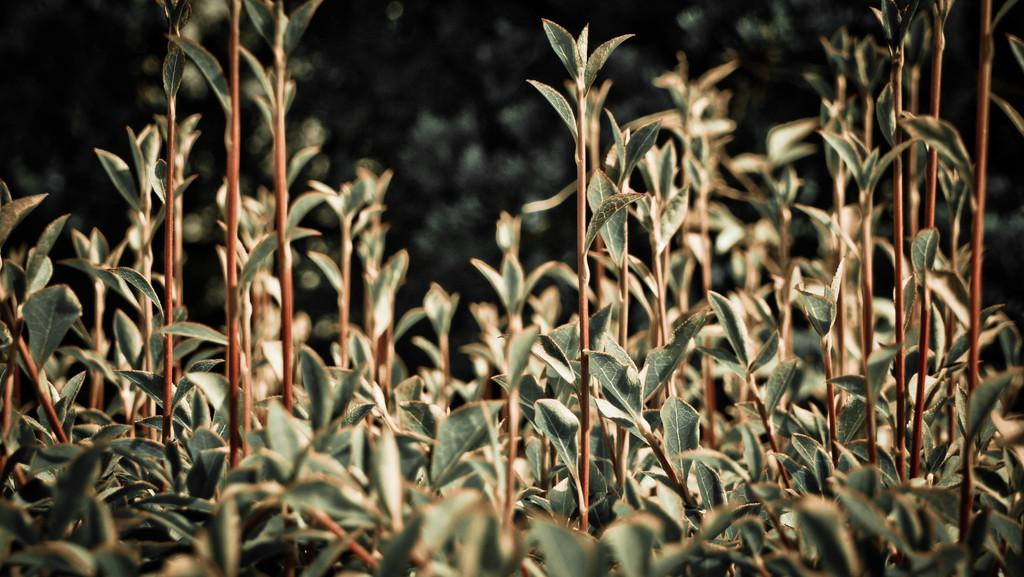What type of living organisms are in the image? There are plants in the image. What colors can be seen on the plants? The plants have green and brown colors. How would you describe the background of the image? The background of the image is blurry and has black and green colors. How many holes can be seen in the plants in the image? There are no holes visible in the plants in the image. What type of eye can be seen on the plants in the image? There are no eyes present on the plants in the image. 